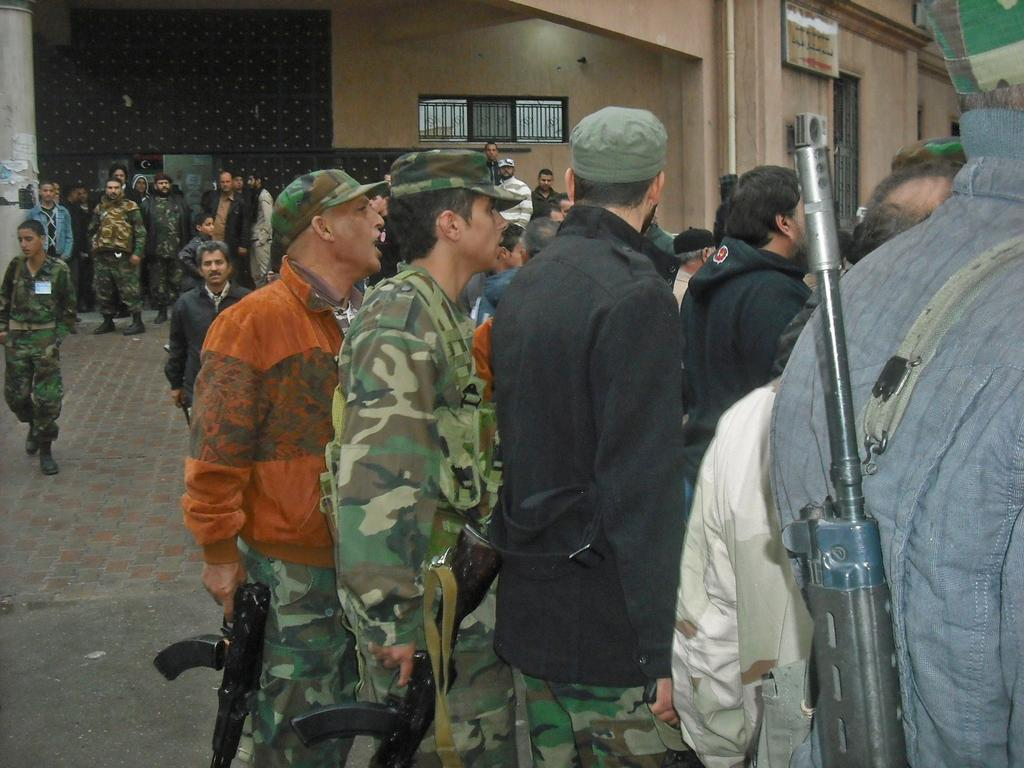How many people are in the image? There are people in the image, but the exact number is not specified. What are the people doing in the image? The people are standing and holding guns in their hands. What can be seen in the background of the image? There is a building in the background of the image. What type of teeth can be seen in the image? There are no teeth visible in the image. What kind of drug is being used by the people in the image? There is no indication of any drug use in the image. 